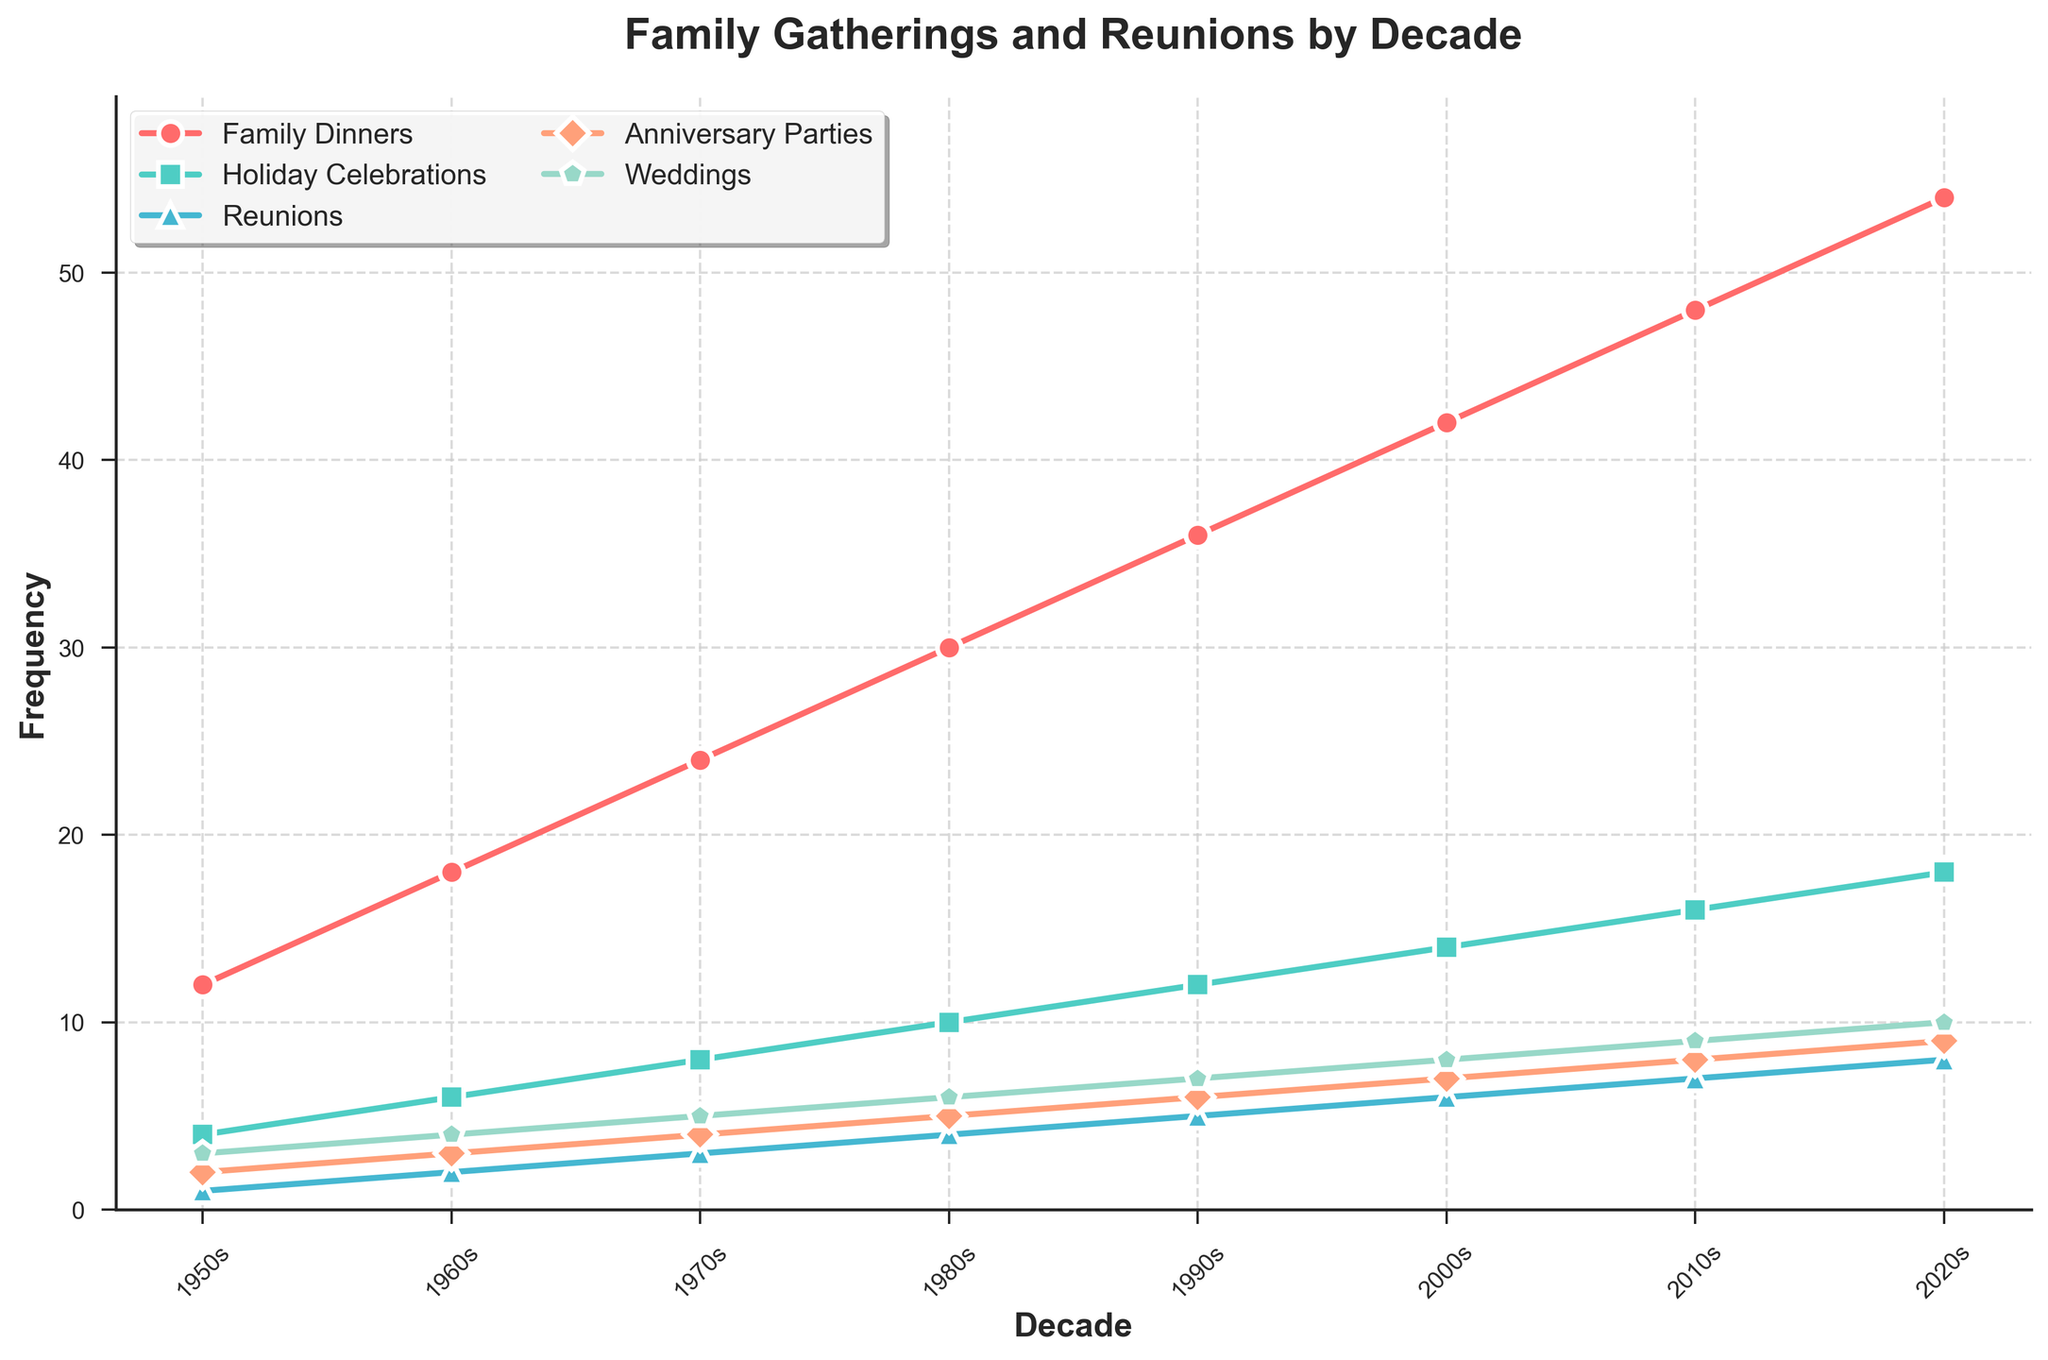What's the frequency of Family Dinners in the 1970s? Look at the line representing Family Dinners, follow it to the 1970s on the x-axis, and read the corresponding y-axis value
Answer: 24 How does the frequency of Holiday Celebrations in the 2010s compare to the 1950s? Check the line representing Holiday Celebrations, find the y-axis values for both the 2010s and 1950s, and compare them. 16 (2010s) is greater than 4 (1950s)
Answer: The frequency is 4 times higher in the 2010s Which event type has the highest frequency in the 2020s? Follow all lines to the 2020s on the x-axis, compare their y-axis values to find the maximum
Answer: Family Dinners Between which decades does the frequency of Reunions double for the first time? Follow the line representing Reunions, identify the first jump that doubles the frequency value between two consecutive decades (from 1 to 2)
Answer: 1950s to 1960s In which decade did Anniversary Parties occur just as often as Family Dinners in the 1950s? Find the frequency of Family Dinners in the 1950s first (12), then find the decade when Anniversary Parties have a frequency of 12
Answer: 1990s How many more times did Weddings occur in the 2000s compared to the 1950s? Compare the values for Weddings in the 2000s and the 1950s: 8 (2000s) - 3 (1950s) = 5
Answer: 5 times What visual color represents Reunions? Locate the line for Reunions and identify its corresponding color from the legend
Answer: Blue What is the overall trend for Family Gatherings and Reunions from the 1950s to the 2020s? Review the lines representing the different event types across decades, noting if they are increasing, decreasing, or stable
Answer: All event types show an increasing trend What is the average value of Holiday Celebrations across all decades? Sum the frequency values of Holiday Celebrations: 4 + 6 + 8 + 10 + 12 + 14 + 16 + 18 = 88, then divide by the number of decades (8)
Answer: 11 In which decade did Reunions surpass Family Dinners in the next following decade compared to the 1970s? Locate the Reunions value for the 1970s (3). Then, identify the next decade where Reunions value (4+) surpasses Family Dinners (3)
Answer: Never (Family Dinners always remained higher) 